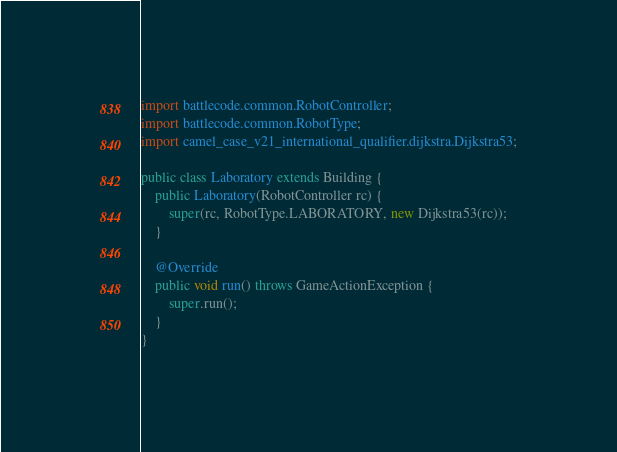Convert code to text. <code><loc_0><loc_0><loc_500><loc_500><_Java_>import battlecode.common.RobotController;
import battlecode.common.RobotType;
import camel_case_v21_international_qualifier.dijkstra.Dijkstra53;

public class Laboratory extends Building {
    public Laboratory(RobotController rc) {
        super(rc, RobotType.LABORATORY, new Dijkstra53(rc));
    }

    @Override
    public void run() throws GameActionException {
        super.run();
    }
}
</code> 